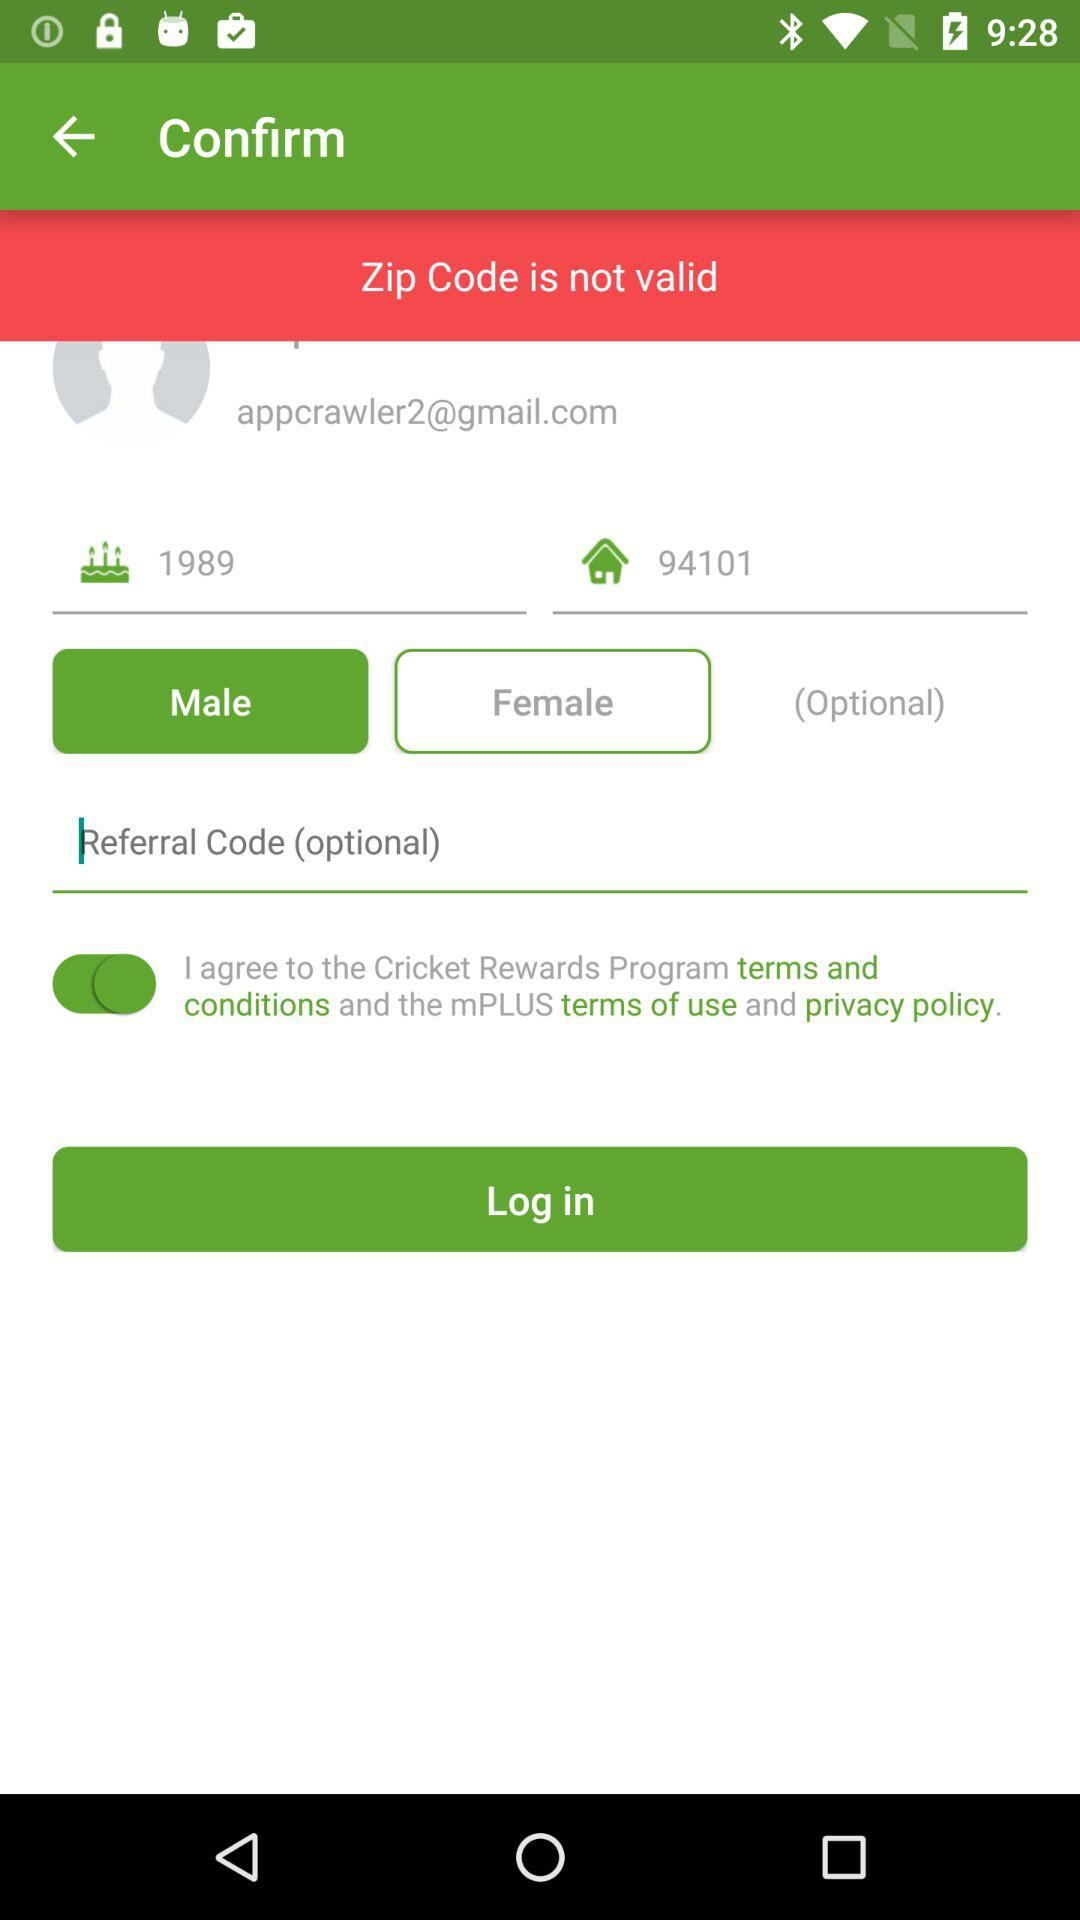What is not valid? The zip code is not valid. 